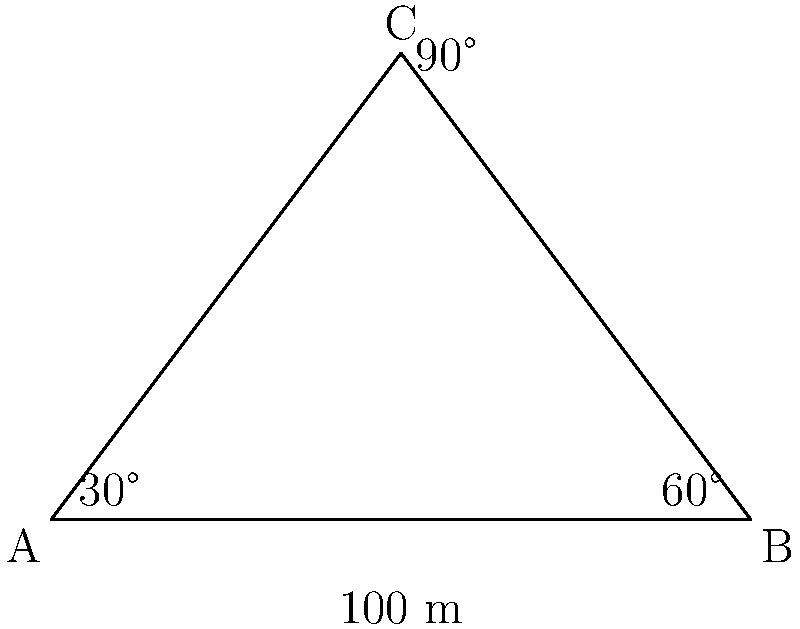At a railway crossing, the visibility triangle forms a right-angled triangle ABC. The crossing angle is 30°, and the distance between the track and the road at the point of intersection is 100 meters. Calculate the minimum visibility distance along the road (AC) required for safe crossing. To solve this problem, we'll use trigonometry in the right-angled triangle ABC:

1. We know that angle BAC is 30° and angle ACB is 90°.
2. The remaining angle ABC must be 60° (sum of angles in a triangle is 180°).
3. The given distance AB is 100 meters.
4. We need to find AC, which is opposite to the 60° angle.

Using the sine rule:

$$\frac{AC}{\sin 60°} = \frac{AB}{\sin 30°}$$

Rearranging:

$$AC = \frac{AB \times \sin 60°}{\sin 30°}$$

Substituting known values:

$$AC = \frac{100 \times \sin 60°}{\sin 30°}$$

Simplifying (knowing that $\sin 60° = \frac{\sqrt{3}}{2}$ and $\sin 30° = \frac{1}{2}$):

$$AC = \frac{100 \times \frac{\sqrt{3}}{2}}{\frac{1}{2}} = 100 \sqrt{3}$$

Therefore, the minimum visibility distance along the road (AC) is $100\sqrt{3}$ meters.
Answer: $100\sqrt{3}$ meters 